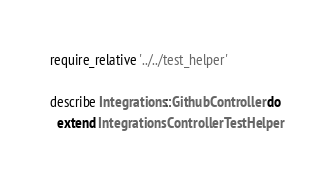Convert code to text. <code><loc_0><loc_0><loc_500><loc_500><_Ruby_>require_relative '../../test_helper'

describe Integrations::GithubController do
  extend IntegrationsControllerTestHelper
</code> 